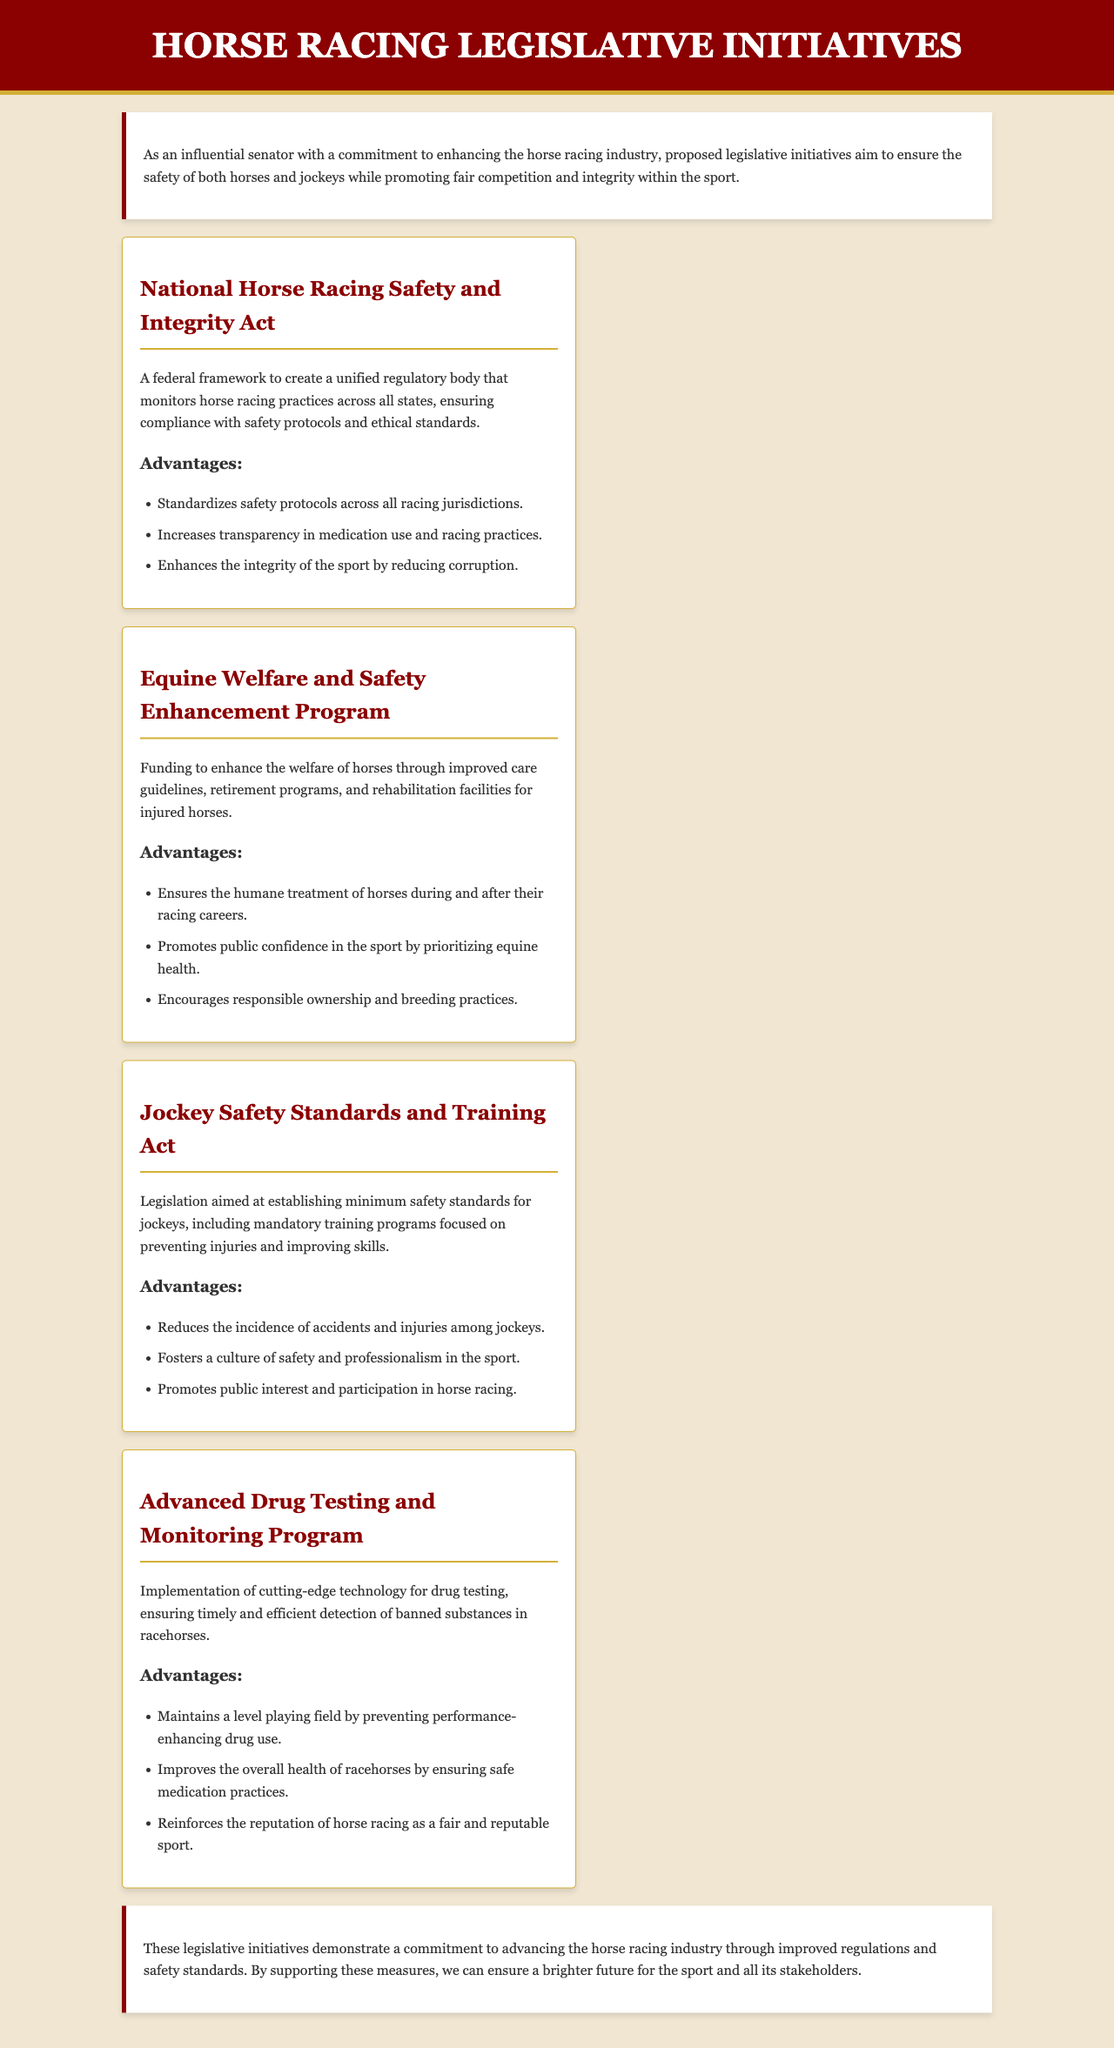What is the title of the document? The title of the document is presented prominently at the top and states the purpose of the content.
Answer: Horse Racing Legislative Initiatives What is the first initiative mentioned? The document lists several legislative initiatives, and the first one listed is the one at the top of the initiatives section.
Answer: National Horse Racing Safety and Integrity Act What is one advantage of the Equine Welfare and Safety Enhancement Program? The document provides several advantages of this initiative, which is focused on the welfare of horses.
Answer: Ensures the humane treatment of horses during and after their racing careers What is the focus of the Jockey Safety Standards and Training Act? The document describes this initiative's primary objective, which revolves around the safety of jockeys.
Answer: Establishing minimum safety standards for jockeys What does the Advanced Drug Testing and Monitoring Program aim to implement? The document outlines the purpose of this program related to the use of technology.
Answer: Implementation of cutting-edge technology for drug testing What is a key goal of the proposed initiatives overall? The summary provides insight into the collective purpose of the proposed initiatives regarding the horse racing industry.
Answer: Advancing the horse racing industry through improved regulations and safety standards 